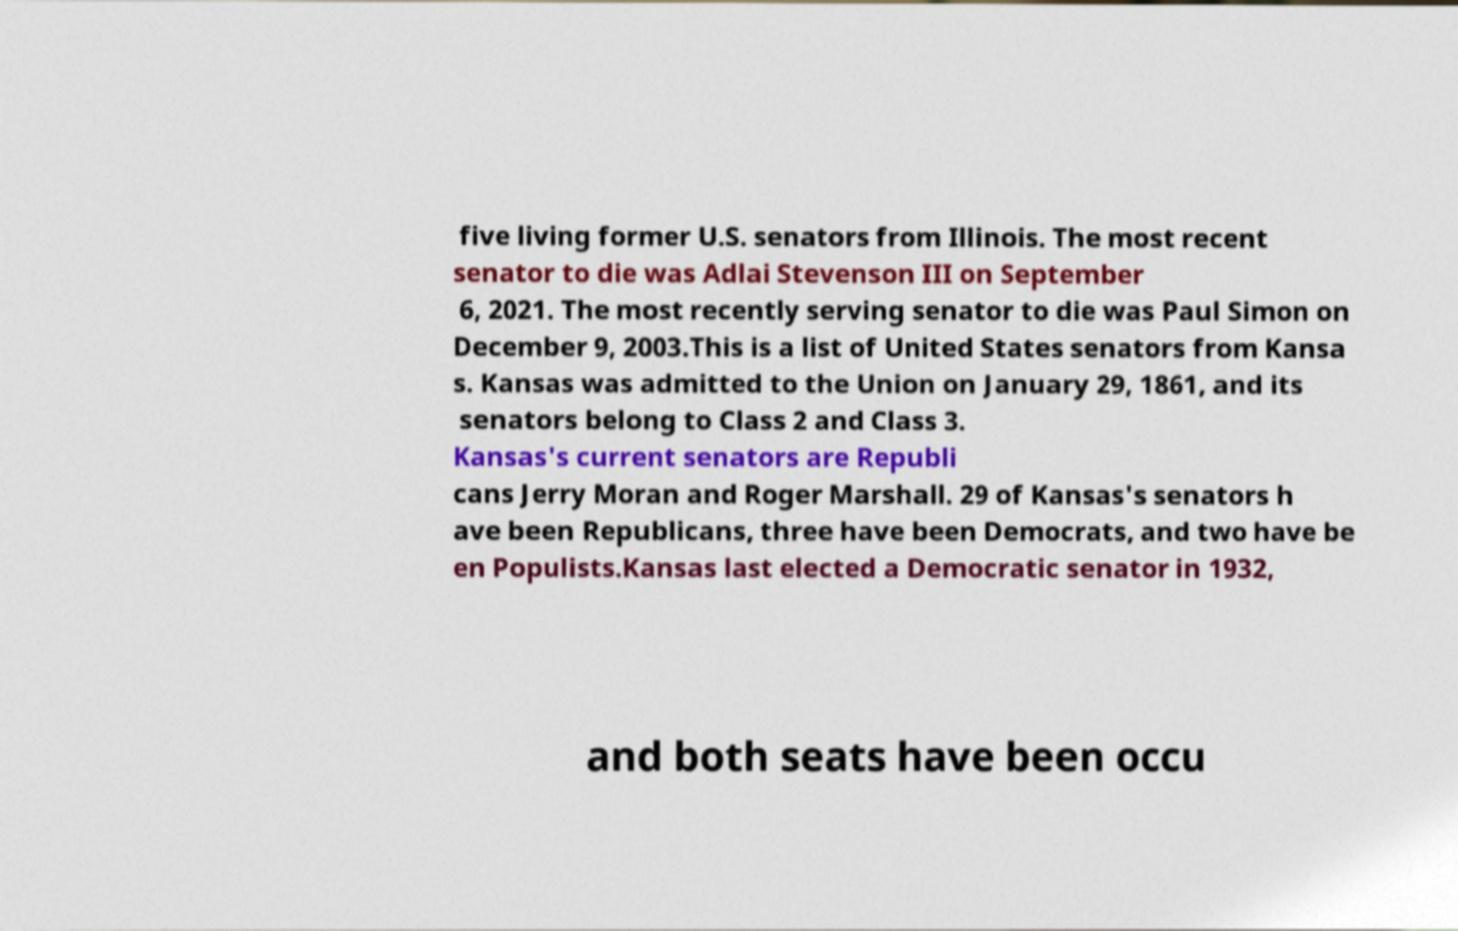Can you accurately transcribe the text from the provided image for me? five living former U.S. senators from Illinois. The most recent senator to die was Adlai Stevenson III on September 6, 2021. The most recently serving senator to die was Paul Simon on December 9, 2003.This is a list of United States senators from Kansa s. Kansas was admitted to the Union on January 29, 1861, and its senators belong to Class 2 and Class 3. Kansas's current senators are Republi cans Jerry Moran and Roger Marshall. 29 of Kansas's senators h ave been Republicans, three have been Democrats, and two have be en Populists.Kansas last elected a Democratic senator in 1932, and both seats have been occu 